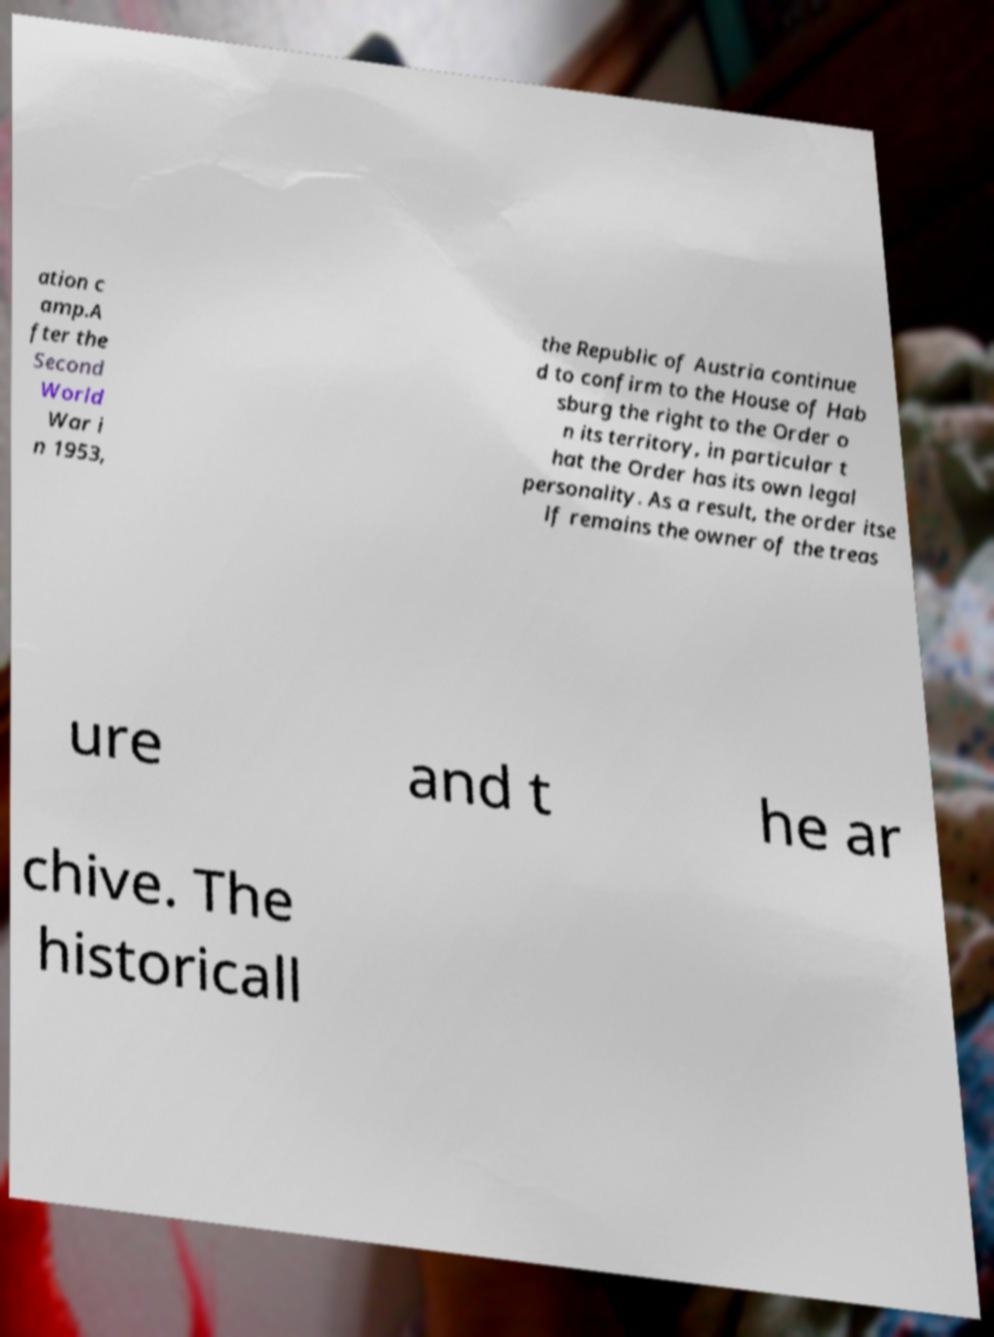Can you accurately transcribe the text from the provided image for me? ation c amp.A fter the Second World War i n 1953, the Republic of Austria continue d to confirm to the House of Hab sburg the right to the Order o n its territory, in particular t hat the Order has its own legal personality. As a result, the order itse lf remains the owner of the treas ure and t he ar chive. The historicall 